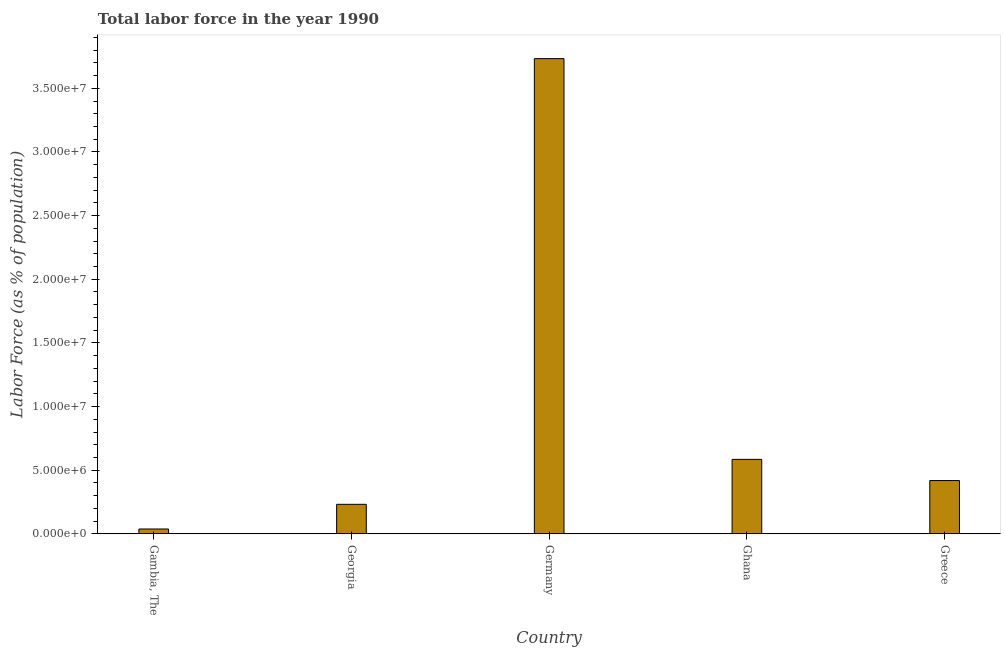Does the graph contain any zero values?
Provide a short and direct response. No. Does the graph contain grids?
Offer a very short reply. No. What is the title of the graph?
Provide a succinct answer. Total labor force in the year 1990. What is the label or title of the Y-axis?
Your answer should be compact. Labor Force (as % of population). What is the total labor force in Germany?
Make the answer very short. 3.73e+07. Across all countries, what is the maximum total labor force?
Make the answer very short. 3.73e+07. Across all countries, what is the minimum total labor force?
Provide a short and direct response. 3.83e+05. In which country was the total labor force minimum?
Provide a succinct answer. Gambia, The. What is the sum of the total labor force?
Your response must be concise. 5.01e+07. What is the difference between the total labor force in Gambia, The and Greece?
Provide a succinct answer. -3.80e+06. What is the average total labor force per country?
Keep it short and to the point. 1.00e+07. What is the median total labor force?
Make the answer very short. 4.19e+06. What is the ratio of the total labor force in Gambia, The to that in Germany?
Give a very brief answer. 0.01. Is the difference between the total labor force in Gambia, The and Germany greater than the difference between any two countries?
Give a very brief answer. Yes. What is the difference between the highest and the second highest total labor force?
Keep it short and to the point. 3.15e+07. What is the difference between the highest and the lowest total labor force?
Keep it short and to the point. 3.69e+07. In how many countries, is the total labor force greater than the average total labor force taken over all countries?
Give a very brief answer. 1. How many bars are there?
Make the answer very short. 5. Are all the bars in the graph horizontal?
Offer a very short reply. No. How many countries are there in the graph?
Ensure brevity in your answer.  5. What is the Labor Force (as % of population) of Gambia, The?
Your answer should be compact. 3.83e+05. What is the Labor Force (as % of population) in Georgia?
Offer a very short reply. 2.32e+06. What is the Labor Force (as % of population) of Germany?
Offer a terse response. 3.73e+07. What is the Labor Force (as % of population) of Ghana?
Give a very brief answer. 5.85e+06. What is the Labor Force (as % of population) of Greece?
Your response must be concise. 4.19e+06. What is the difference between the Labor Force (as % of population) in Gambia, The and Georgia?
Make the answer very short. -1.94e+06. What is the difference between the Labor Force (as % of population) in Gambia, The and Germany?
Offer a terse response. -3.69e+07. What is the difference between the Labor Force (as % of population) in Gambia, The and Ghana?
Your answer should be very brief. -5.47e+06. What is the difference between the Labor Force (as % of population) in Gambia, The and Greece?
Provide a succinct answer. -3.80e+06. What is the difference between the Labor Force (as % of population) in Georgia and Germany?
Your answer should be very brief. -3.50e+07. What is the difference between the Labor Force (as % of population) in Georgia and Ghana?
Give a very brief answer. -3.53e+06. What is the difference between the Labor Force (as % of population) in Georgia and Greece?
Your answer should be compact. -1.87e+06. What is the difference between the Labor Force (as % of population) in Germany and Ghana?
Your answer should be compact. 3.15e+07. What is the difference between the Labor Force (as % of population) in Germany and Greece?
Your response must be concise. 3.31e+07. What is the difference between the Labor Force (as % of population) in Ghana and Greece?
Your response must be concise. 1.66e+06. What is the ratio of the Labor Force (as % of population) in Gambia, The to that in Georgia?
Make the answer very short. 0.17. What is the ratio of the Labor Force (as % of population) in Gambia, The to that in Germany?
Your answer should be compact. 0.01. What is the ratio of the Labor Force (as % of population) in Gambia, The to that in Ghana?
Make the answer very short. 0.07. What is the ratio of the Labor Force (as % of population) in Gambia, The to that in Greece?
Offer a very short reply. 0.09. What is the ratio of the Labor Force (as % of population) in Georgia to that in Germany?
Offer a terse response. 0.06. What is the ratio of the Labor Force (as % of population) in Georgia to that in Ghana?
Offer a terse response. 0.4. What is the ratio of the Labor Force (as % of population) in Georgia to that in Greece?
Your answer should be very brief. 0.55. What is the ratio of the Labor Force (as % of population) in Germany to that in Ghana?
Your answer should be very brief. 6.38. What is the ratio of the Labor Force (as % of population) in Germany to that in Greece?
Give a very brief answer. 8.91. What is the ratio of the Labor Force (as % of population) in Ghana to that in Greece?
Make the answer very short. 1.4. 